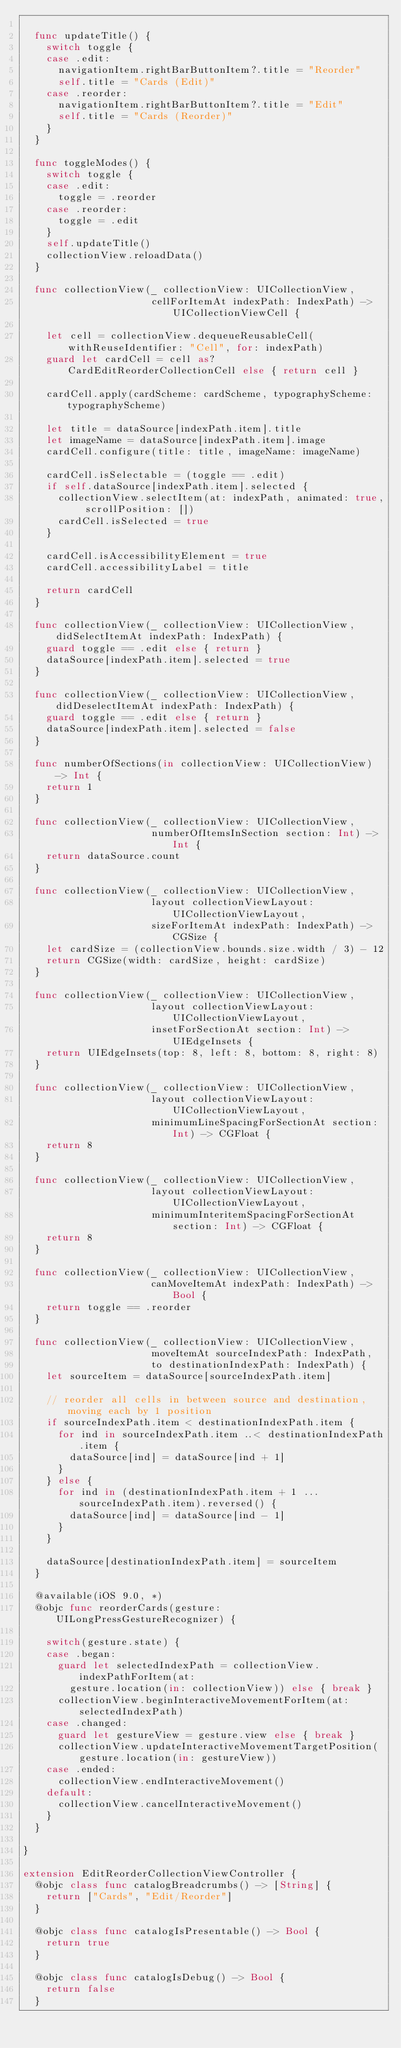Convert code to text. <code><loc_0><loc_0><loc_500><loc_500><_Swift_>
  func updateTitle() {
    switch toggle {
    case .edit:
      navigationItem.rightBarButtonItem?.title = "Reorder"
      self.title = "Cards (Edit)"
    case .reorder:
      navigationItem.rightBarButtonItem?.title = "Edit"
      self.title = "Cards (Reorder)"
    }
  }

  func toggleModes() {
    switch toggle {
    case .edit:
      toggle = .reorder
    case .reorder:
      toggle = .edit
    }
    self.updateTitle()
    collectionView.reloadData()
  }

  func collectionView(_ collectionView: UICollectionView,
                      cellForItemAt indexPath: IndexPath) -> UICollectionViewCell {

    let cell = collectionView.dequeueReusableCell(withReuseIdentifier: "Cell", for: indexPath)
    guard let cardCell = cell as? CardEditReorderCollectionCell else { return cell }

    cardCell.apply(cardScheme: cardScheme, typographyScheme: typographyScheme)

    let title = dataSource[indexPath.item].title
    let imageName = dataSource[indexPath.item].image
    cardCell.configure(title: title, imageName: imageName)

    cardCell.isSelectable = (toggle == .edit)
    if self.dataSource[indexPath.item].selected {
      collectionView.selectItem(at: indexPath, animated: true, scrollPosition: [])
      cardCell.isSelected = true
    }

    cardCell.isAccessibilityElement = true
    cardCell.accessibilityLabel = title

    return cardCell
  }

  func collectionView(_ collectionView: UICollectionView, didSelectItemAt indexPath: IndexPath) {
    guard toggle == .edit else { return }
    dataSource[indexPath.item].selected = true
  }

  func collectionView(_ collectionView: UICollectionView, didDeselectItemAt indexPath: IndexPath) {
    guard toggle == .edit else { return }
    dataSource[indexPath.item].selected = false
  }

  func numberOfSections(in collectionView: UICollectionView) -> Int {
    return 1
  }

  func collectionView(_ collectionView: UICollectionView,
                      numberOfItemsInSection section: Int) -> Int {
    return dataSource.count
  }

  func collectionView(_ collectionView: UICollectionView,
                      layout collectionViewLayout: UICollectionViewLayout,
                      sizeForItemAt indexPath: IndexPath) -> CGSize {
    let cardSize = (collectionView.bounds.size.width / 3) - 12
    return CGSize(width: cardSize, height: cardSize)
  }

  func collectionView(_ collectionView: UICollectionView,
                      layout collectionViewLayout: UICollectionViewLayout,
                      insetForSectionAt section: Int) -> UIEdgeInsets {
    return UIEdgeInsets(top: 8, left: 8, bottom: 8, right: 8)
  }

  func collectionView(_ collectionView: UICollectionView,
                      layout collectionViewLayout: UICollectionViewLayout,
                      minimumLineSpacingForSectionAt section: Int) -> CGFloat {
    return 8
  }

  func collectionView(_ collectionView: UICollectionView,
                      layout collectionViewLayout: UICollectionViewLayout,
                      minimumInteritemSpacingForSectionAt section: Int) -> CGFloat {
    return 8
  }

  func collectionView(_ collectionView: UICollectionView,
                      canMoveItemAt indexPath: IndexPath) -> Bool {
    return toggle == .reorder
  }

  func collectionView(_ collectionView: UICollectionView,
                      moveItemAt sourceIndexPath: IndexPath,
                      to destinationIndexPath: IndexPath) {
    let sourceItem = dataSource[sourceIndexPath.item]

    // reorder all cells in between source and destination, moving each by 1 position
    if sourceIndexPath.item < destinationIndexPath.item {
      for ind in sourceIndexPath.item ..< destinationIndexPath.item {
        dataSource[ind] = dataSource[ind + 1]
      }
    } else {
      for ind in (destinationIndexPath.item + 1 ... sourceIndexPath.item).reversed() {
        dataSource[ind] = dataSource[ind - 1]
      }
    }

    dataSource[destinationIndexPath.item] = sourceItem
  }

  @available(iOS 9.0, *)
  @objc func reorderCards(gesture: UILongPressGestureRecognizer) {

    switch(gesture.state) {
    case .began:
      guard let selectedIndexPath = collectionView.indexPathForItem(at:
        gesture.location(in: collectionView)) else { break }
      collectionView.beginInteractiveMovementForItem(at: selectedIndexPath)
    case .changed:
      guard let gestureView = gesture.view else { break }
      collectionView.updateInteractiveMovementTargetPosition(gesture.location(in: gestureView))
    case .ended:
      collectionView.endInteractiveMovement()
    default:
      collectionView.cancelInteractiveMovement()
    }
  }

}

extension EditReorderCollectionViewController {
  @objc class func catalogBreadcrumbs() -> [String] {
    return ["Cards", "Edit/Reorder"]
  }

  @objc class func catalogIsPresentable() -> Bool {
    return true
  }

  @objc class func catalogIsDebug() -> Bool {
    return false
  }
</code> 